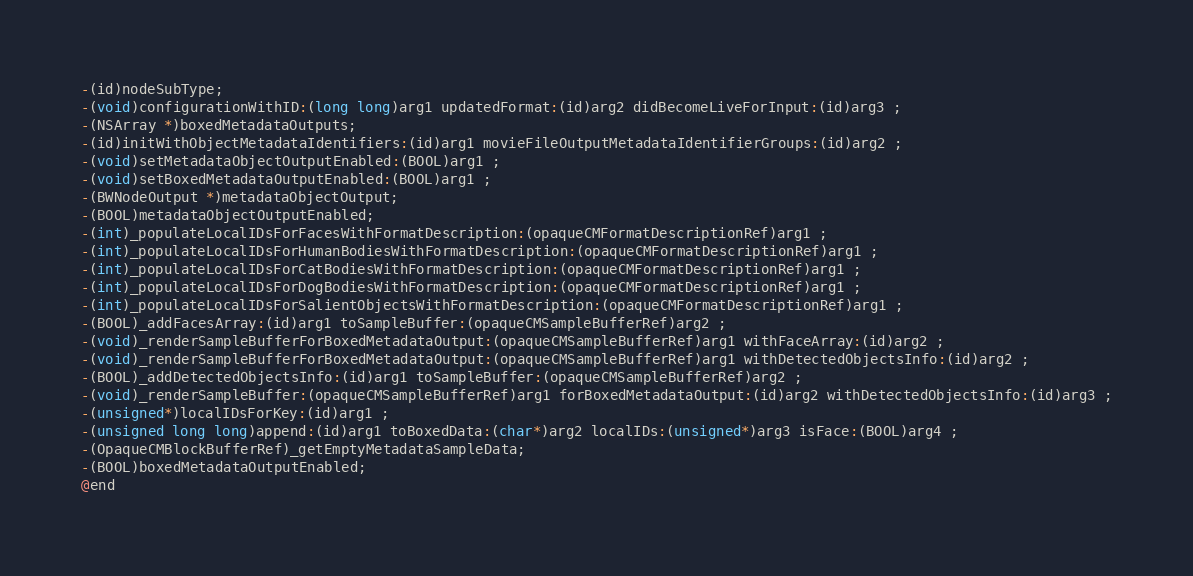Convert code to text. <code><loc_0><loc_0><loc_500><loc_500><_C_>-(id)nodeSubType;
-(void)configurationWithID:(long long)arg1 updatedFormat:(id)arg2 didBecomeLiveForInput:(id)arg3 ;
-(NSArray *)boxedMetadataOutputs;
-(id)initWithObjectMetadataIdentifiers:(id)arg1 movieFileOutputMetadataIdentifierGroups:(id)arg2 ;
-(void)setMetadataObjectOutputEnabled:(BOOL)arg1 ;
-(void)setBoxedMetadataOutputEnabled:(BOOL)arg1 ;
-(BWNodeOutput *)metadataObjectOutput;
-(BOOL)metadataObjectOutputEnabled;
-(int)_populateLocalIDsForFacesWithFormatDescription:(opaqueCMFormatDescriptionRef)arg1 ;
-(int)_populateLocalIDsForHumanBodiesWithFormatDescription:(opaqueCMFormatDescriptionRef)arg1 ;
-(int)_populateLocalIDsForCatBodiesWithFormatDescription:(opaqueCMFormatDescriptionRef)arg1 ;
-(int)_populateLocalIDsForDogBodiesWithFormatDescription:(opaqueCMFormatDescriptionRef)arg1 ;
-(int)_populateLocalIDsForSalientObjectsWithFormatDescription:(opaqueCMFormatDescriptionRef)arg1 ;
-(BOOL)_addFacesArray:(id)arg1 toSampleBuffer:(opaqueCMSampleBufferRef)arg2 ;
-(void)_renderSampleBufferForBoxedMetadataOutput:(opaqueCMSampleBufferRef)arg1 withFaceArray:(id)arg2 ;
-(void)_renderSampleBufferForBoxedMetadataOutput:(opaqueCMSampleBufferRef)arg1 withDetectedObjectsInfo:(id)arg2 ;
-(BOOL)_addDetectedObjectsInfo:(id)arg1 toSampleBuffer:(opaqueCMSampleBufferRef)arg2 ;
-(void)_renderSampleBuffer:(opaqueCMSampleBufferRef)arg1 forBoxedMetadataOutput:(id)arg2 withDetectedObjectsInfo:(id)arg3 ;
-(unsigned*)localIDsForKey:(id)arg1 ;
-(unsigned long long)append:(id)arg1 toBoxedData:(char*)arg2 localIDs:(unsigned*)arg3 isFace:(BOOL)arg4 ;
-(OpaqueCMBlockBufferRef)_getEmptyMetadataSampleData;
-(BOOL)boxedMetadataOutputEnabled;
@end

</code> 